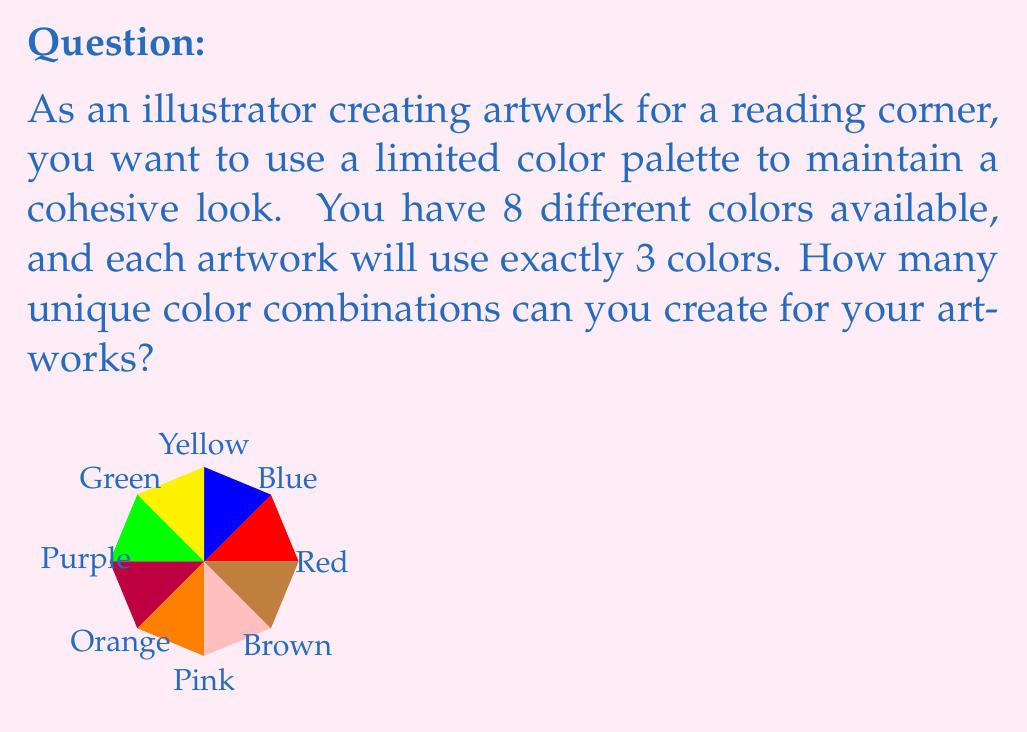Provide a solution to this math problem. To solve this problem, we need to use the combination formula from combinatorics. We are selecting 3 colors from a set of 8 colors, where the order doesn't matter (e.g., using red, blue, and yellow is the same combination as using blue, yellow, and red).

The formula for combinations is:

$$ C(n,r) = \frac{n!}{r!(n-r)!} $$

Where:
$n$ is the total number of items to choose from (in this case, 8 colors)
$r$ is the number of items being chosen (in this case, 3 colors)

Let's plug in our values:

$$ C(8,3) = \frac{8!}{3!(8-3)!} = \frac{8!}{3!5!} $$

Now, let's calculate this step-by-step:

1) $8! = 8 \times 7 \times 6 \times 5!$
2) $3! = 3 \times 2 \times 1 = 6$

Substituting these values:

$$ \frac{8 \times 7 \times 6 \times 5!}{6 \times 5!} $$

The $5!$ cancels out in the numerator and denominator:

$$ \frac{8 \times 7 \times 6}{6} = 8 \times 7 = 56 $$

Therefore, there are 56 unique color combinations possible for your artworks.
Answer: 56 combinations 